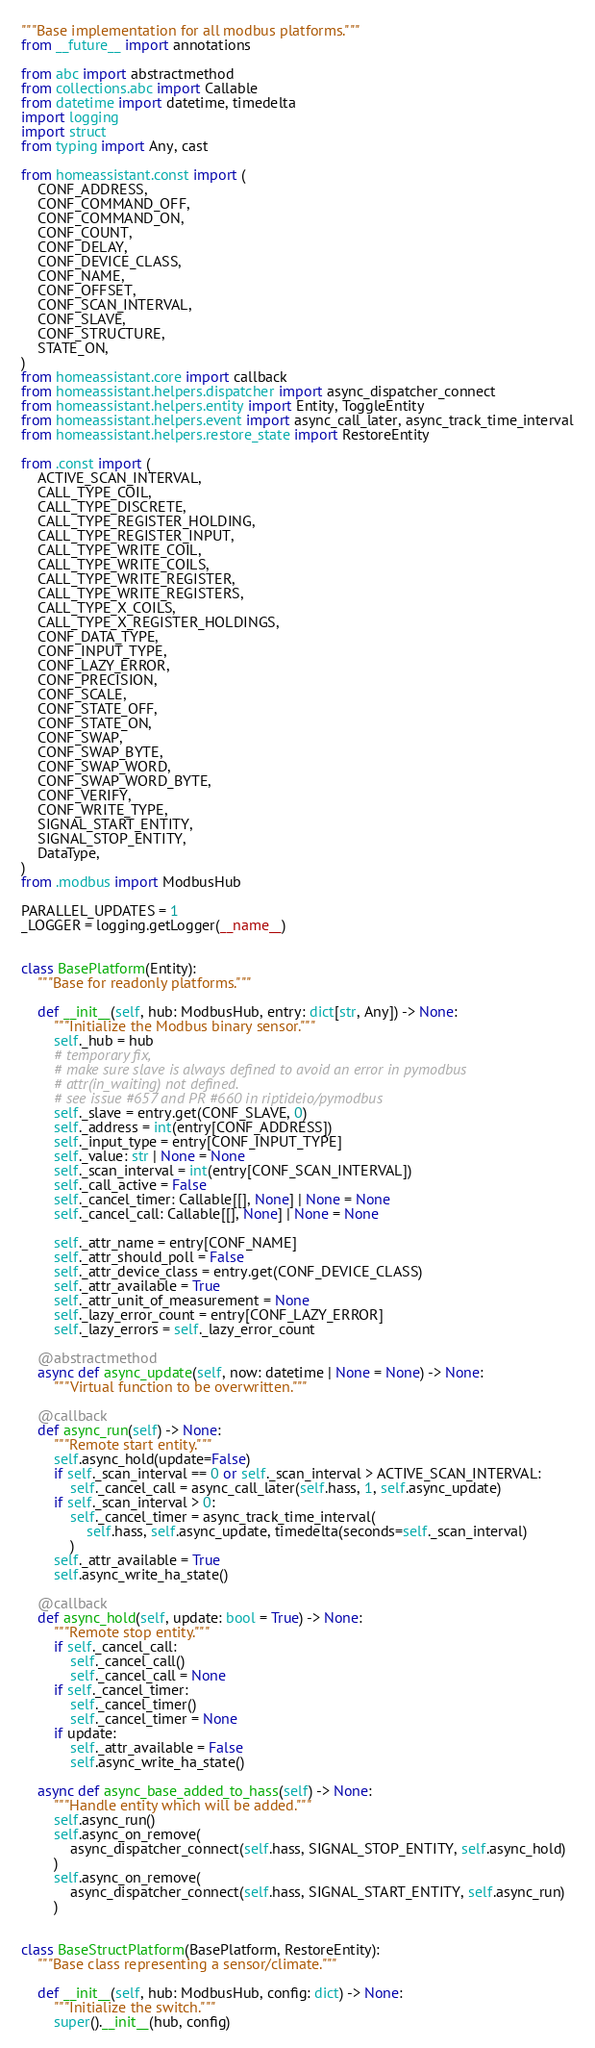<code> <loc_0><loc_0><loc_500><loc_500><_Python_>"""Base implementation for all modbus platforms."""
from __future__ import annotations

from abc import abstractmethod
from collections.abc import Callable
from datetime import datetime, timedelta
import logging
import struct
from typing import Any, cast

from homeassistant.const import (
    CONF_ADDRESS,
    CONF_COMMAND_OFF,
    CONF_COMMAND_ON,
    CONF_COUNT,
    CONF_DELAY,
    CONF_DEVICE_CLASS,
    CONF_NAME,
    CONF_OFFSET,
    CONF_SCAN_INTERVAL,
    CONF_SLAVE,
    CONF_STRUCTURE,
    STATE_ON,
)
from homeassistant.core import callback
from homeassistant.helpers.dispatcher import async_dispatcher_connect
from homeassistant.helpers.entity import Entity, ToggleEntity
from homeassistant.helpers.event import async_call_later, async_track_time_interval
from homeassistant.helpers.restore_state import RestoreEntity

from .const import (
    ACTIVE_SCAN_INTERVAL,
    CALL_TYPE_COIL,
    CALL_TYPE_DISCRETE,
    CALL_TYPE_REGISTER_HOLDING,
    CALL_TYPE_REGISTER_INPUT,
    CALL_TYPE_WRITE_COIL,
    CALL_TYPE_WRITE_COILS,
    CALL_TYPE_WRITE_REGISTER,
    CALL_TYPE_WRITE_REGISTERS,
    CALL_TYPE_X_COILS,
    CALL_TYPE_X_REGISTER_HOLDINGS,
    CONF_DATA_TYPE,
    CONF_INPUT_TYPE,
    CONF_LAZY_ERROR,
    CONF_PRECISION,
    CONF_SCALE,
    CONF_STATE_OFF,
    CONF_STATE_ON,
    CONF_SWAP,
    CONF_SWAP_BYTE,
    CONF_SWAP_WORD,
    CONF_SWAP_WORD_BYTE,
    CONF_VERIFY,
    CONF_WRITE_TYPE,
    SIGNAL_START_ENTITY,
    SIGNAL_STOP_ENTITY,
    DataType,
)
from .modbus import ModbusHub

PARALLEL_UPDATES = 1
_LOGGER = logging.getLogger(__name__)


class BasePlatform(Entity):
    """Base for readonly platforms."""

    def __init__(self, hub: ModbusHub, entry: dict[str, Any]) -> None:
        """Initialize the Modbus binary sensor."""
        self._hub = hub
        # temporary fix,
        # make sure slave is always defined to avoid an error in pymodbus
        # attr(in_waiting) not defined.
        # see issue #657 and PR #660 in riptideio/pymodbus
        self._slave = entry.get(CONF_SLAVE, 0)
        self._address = int(entry[CONF_ADDRESS])
        self._input_type = entry[CONF_INPUT_TYPE]
        self._value: str | None = None
        self._scan_interval = int(entry[CONF_SCAN_INTERVAL])
        self._call_active = False
        self._cancel_timer: Callable[[], None] | None = None
        self._cancel_call: Callable[[], None] | None = None

        self._attr_name = entry[CONF_NAME]
        self._attr_should_poll = False
        self._attr_device_class = entry.get(CONF_DEVICE_CLASS)
        self._attr_available = True
        self._attr_unit_of_measurement = None
        self._lazy_error_count = entry[CONF_LAZY_ERROR]
        self._lazy_errors = self._lazy_error_count

    @abstractmethod
    async def async_update(self, now: datetime | None = None) -> None:
        """Virtual function to be overwritten."""

    @callback
    def async_run(self) -> None:
        """Remote start entity."""
        self.async_hold(update=False)
        if self._scan_interval == 0 or self._scan_interval > ACTIVE_SCAN_INTERVAL:
            self._cancel_call = async_call_later(self.hass, 1, self.async_update)
        if self._scan_interval > 0:
            self._cancel_timer = async_track_time_interval(
                self.hass, self.async_update, timedelta(seconds=self._scan_interval)
            )
        self._attr_available = True
        self.async_write_ha_state()

    @callback
    def async_hold(self, update: bool = True) -> None:
        """Remote stop entity."""
        if self._cancel_call:
            self._cancel_call()
            self._cancel_call = None
        if self._cancel_timer:
            self._cancel_timer()
            self._cancel_timer = None
        if update:
            self._attr_available = False
            self.async_write_ha_state()

    async def async_base_added_to_hass(self) -> None:
        """Handle entity which will be added."""
        self.async_run()
        self.async_on_remove(
            async_dispatcher_connect(self.hass, SIGNAL_STOP_ENTITY, self.async_hold)
        )
        self.async_on_remove(
            async_dispatcher_connect(self.hass, SIGNAL_START_ENTITY, self.async_run)
        )


class BaseStructPlatform(BasePlatform, RestoreEntity):
    """Base class representing a sensor/climate."""

    def __init__(self, hub: ModbusHub, config: dict) -> None:
        """Initialize the switch."""
        super().__init__(hub, config)</code> 